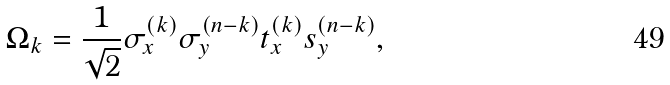<formula> <loc_0><loc_0><loc_500><loc_500>\Omega _ { k } = \frac { 1 } { \sqrt { 2 } } \sigma _ { x } ^ { ( k ) } \sigma _ { y } ^ { ( n - k ) } t _ { x } ^ { ( k ) } s _ { y } ^ { ( n - k ) } ,</formula> 